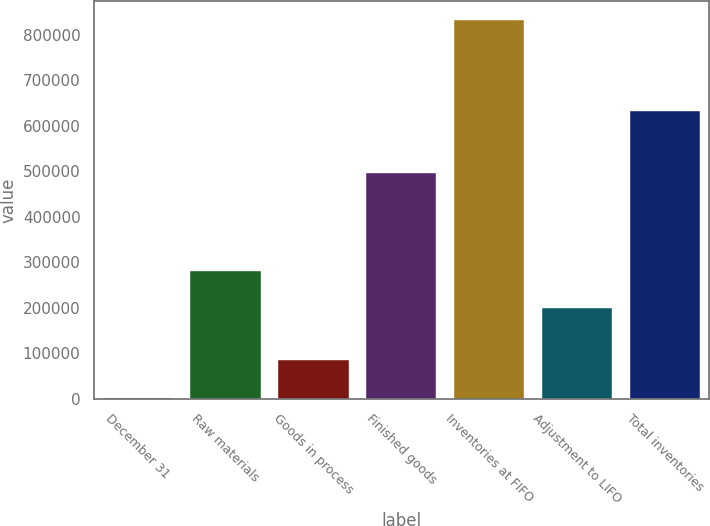<chart> <loc_0><loc_0><loc_500><loc_500><bar_chart><fcel>December 31<fcel>Raw materials<fcel>Goods in process<fcel>Finished goods<fcel>Inventories at FIFO<fcel>Adjustment to LIFO<fcel>Total inventories<nl><fcel>2012<fcel>282003<fcel>85035<fcel>496981<fcel>832242<fcel>198980<fcel>633262<nl></chart> 